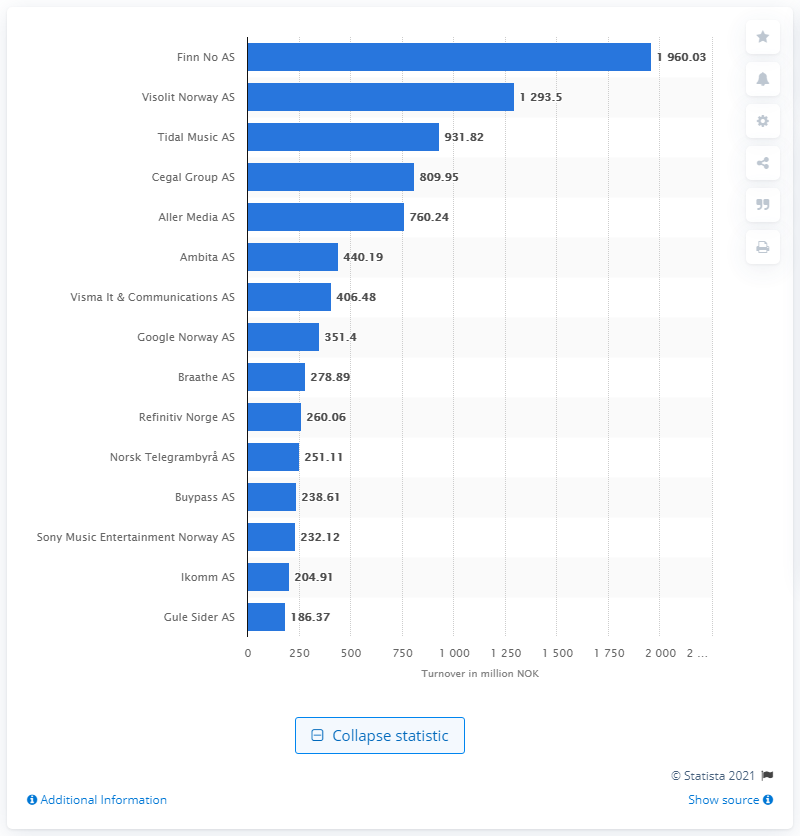Mention a couple of crucial points in this snapshot. Finn No AS had a turnover of 1960.03 Norwegian kroner in March 2021. 